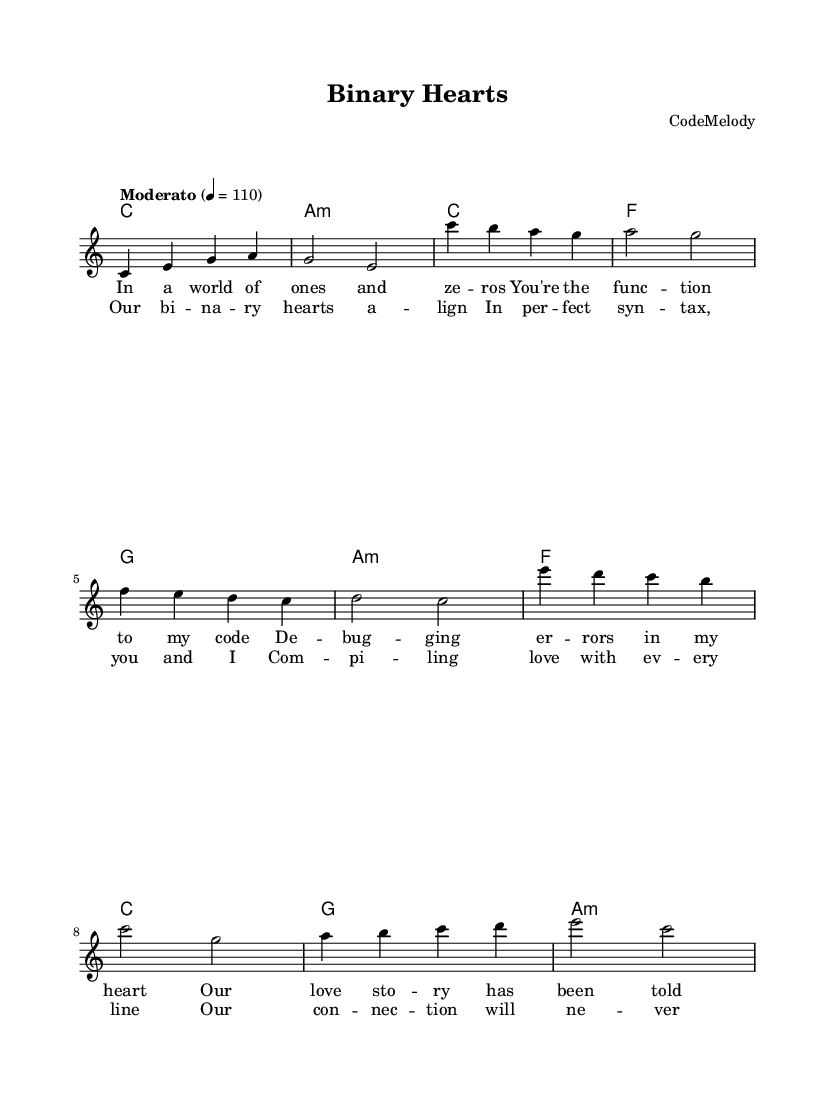What is the key signature of this music? The key signature is indicated at the beginning of the score, where it shows no sharps or flats. This corresponds to C major.
Answer: C major What is the time signature of this music? The time signature is found at the beginning of the score, featuring a pattern that allows four beats per measure. This is indicated as 4/4.
Answer: 4/4 What is the tempo marking for the music? The tempo marking is situated above the staff, indicated as "Moderato" followed by a metronome marking of 110 beats per minute, indicating a moderate speed.
Answer: Moderato How many measures are in the verse section? Counting the measures in the verse, we observe that there are a total of four measures present.
Answer: 4 Which musical term expresses the idea of love in the chorus? The chorus contains the phrase "binary hearts," specifically tying into the romantic theme expressed through programming terminology.
Answer: binary hearts What does the phrase "perfect syntax" suggest about the relationship in the song? The phrase "perfect syntax" metaphorically connects to the idea that the relationship is flawlessly constructed and harmonious, akin to correct programming syntax.
Answer: perfect syntax What is the overall theme of the song? The song expresses a romantic narrative intertwined with programming concepts, suggesting love as a structured connection, as reflected in lyrics about aligning and compiling.
Answer: Romance and programming 